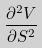<formula> <loc_0><loc_0><loc_500><loc_500>\frac { \partial ^ { 2 } V } { \partial S ^ { 2 } }</formula> 